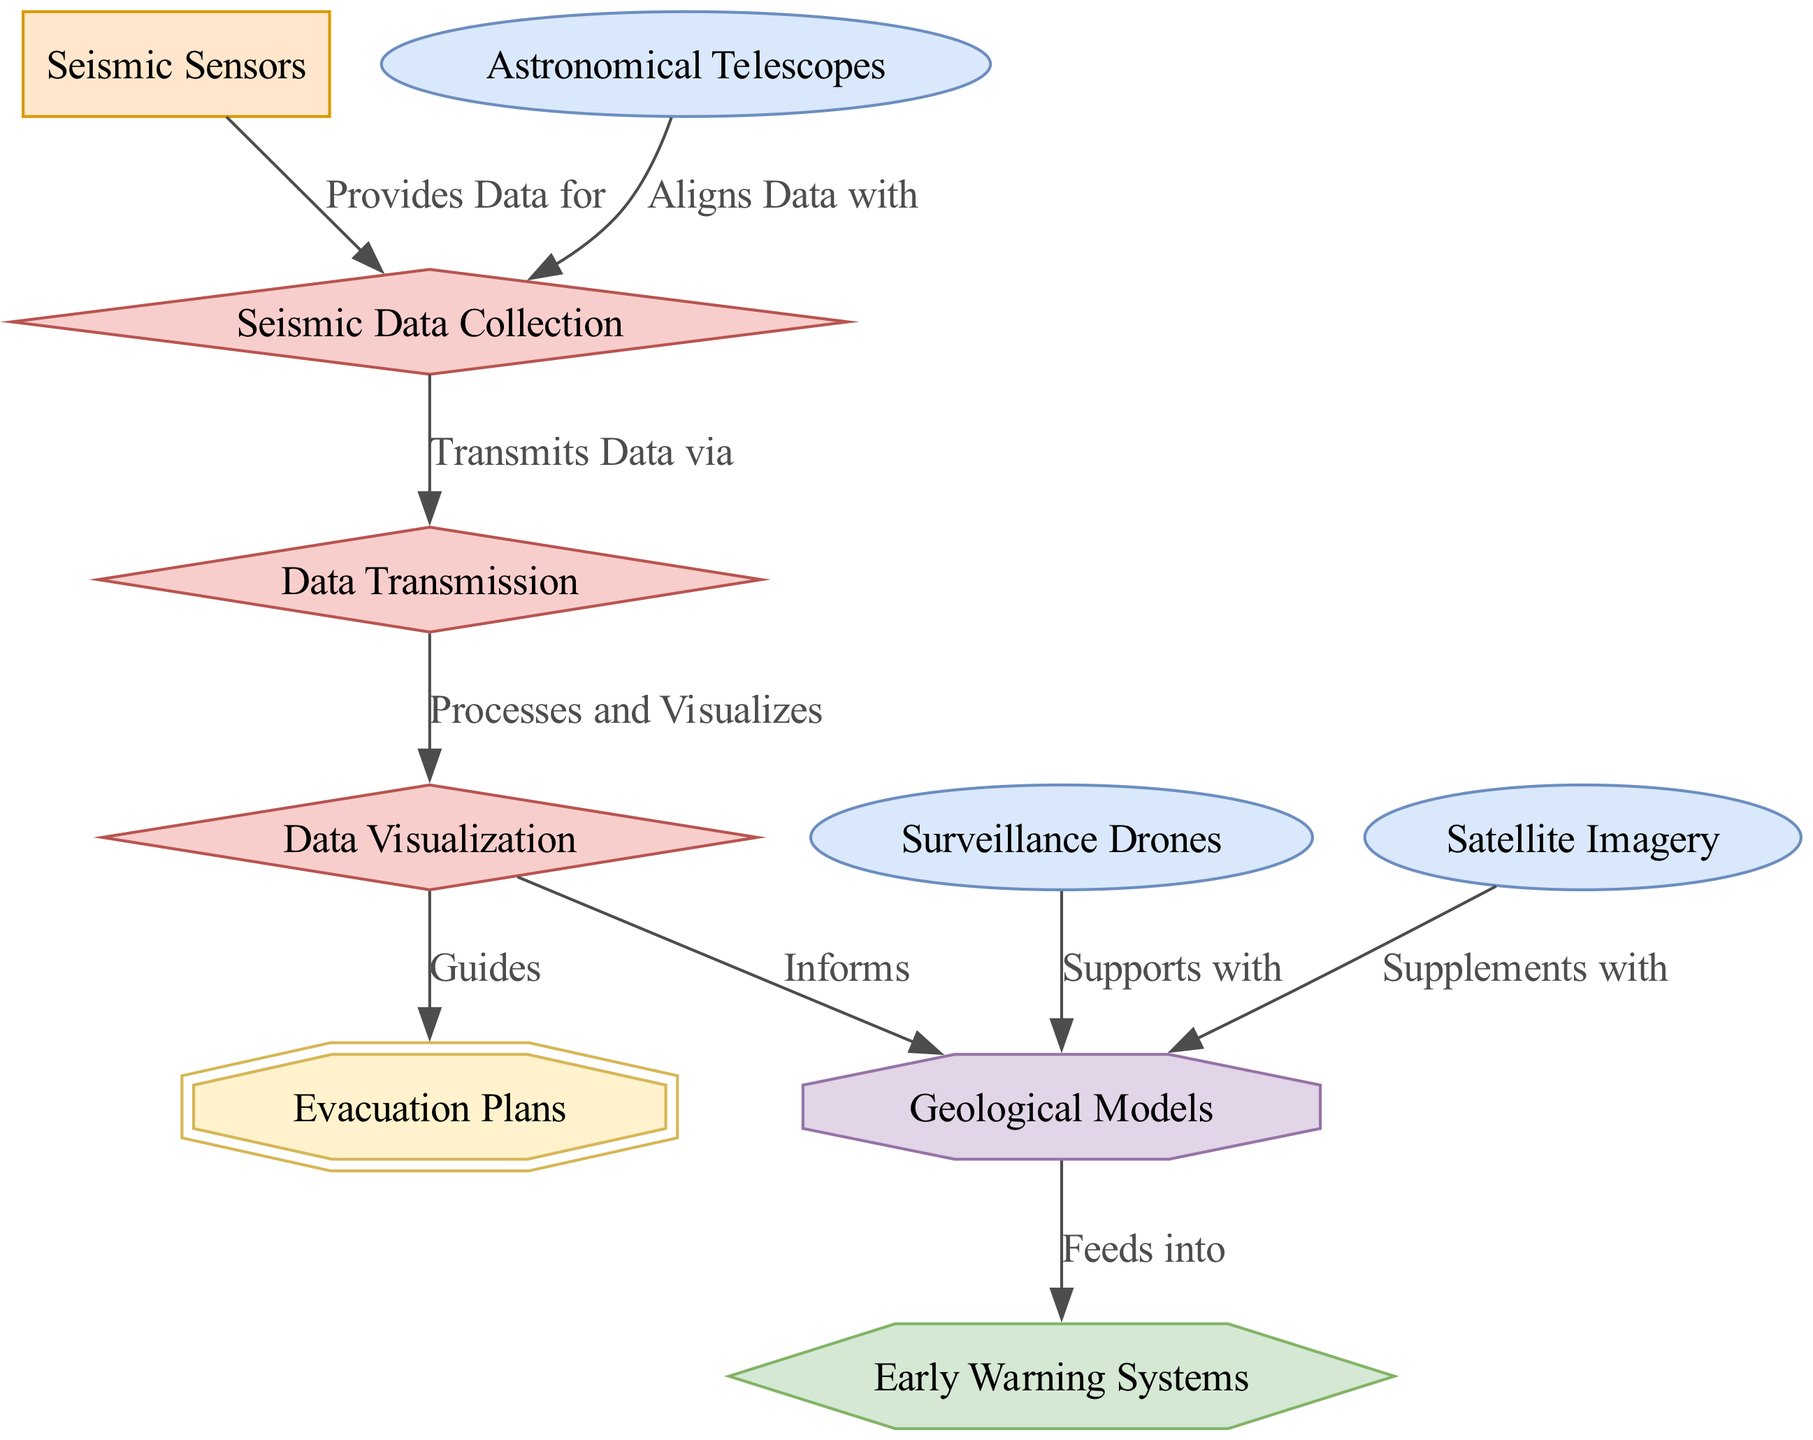What is the total number of nodes in the diagram? To find the total number of nodes, we count the entries listed under "nodes". There are 10 distinct nodes identified by their respective IDs.
Answer: 10 Which instrument aligns data with seismic sensors? The edge labeled "Aligns Data with" connects the node "Astronomical Telescopes" to the node "Seismic Data Collection", indicating that astronomical telescopes are the instruments that align data with seismic sensors.
Answer: Astronomical Telescopes What type of process is "Data Visualization"? The node "Data Visualization" is categorized as a process, as indicated by its type in the diagram.
Answer: process How do surveillance drones contribute to seismic data? Surveillance Drones support geological models with data, as shown by the edge labeled "Supports with" leading from "Surveillance Drones" to "Geological Models".
Answer: geological models What is the role of early warning systems in relation to geological models? The edge labeled "Feeds into" indicates that geological models provide vital information to early warning systems, assisting in alerting about potential eruptions.
Answer: assist in alerting How many processes feed into evacuation plans based on the diagram? The diagram shows that "Data Visualization" is the process that guides the preparation of "Evacuation Plans", indicating one specific process feeds into evacuation plans.
Answer: 1 Which node connects seismic data collection to data transmission? The edge labeled "Transmits Data via" connects the node "Seismic Data Collection" with "Data Transmission", indicating this connection.
Answer: Data Transmission What type of model is included in this diagram? The diagram includes one model type labeled "Geological Models", depicted as an octagonal shape.
Answer: Geological Models Which node sends data from sensors to servers? The edge labeled "Transmits Data via" clearly shows that "Data Transmission" is the process that facilitates the sending of data from "Seismic Data Collection" to the servers.
Answer: Data Transmission 